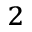Convert formula to latex. <formula><loc_0><loc_0><loc_500><loc_500>_ { 2 }</formula> 